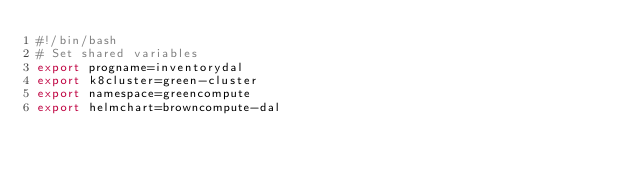Convert code to text. <code><loc_0><loc_0><loc_500><loc_500><_Bash_>#!/bin/bash
# Set shared variables
export progname=inventorydal
export k8cluster=green-cluster
export namespace=greencompute
export helmchart=browncompute-dal
</code> 